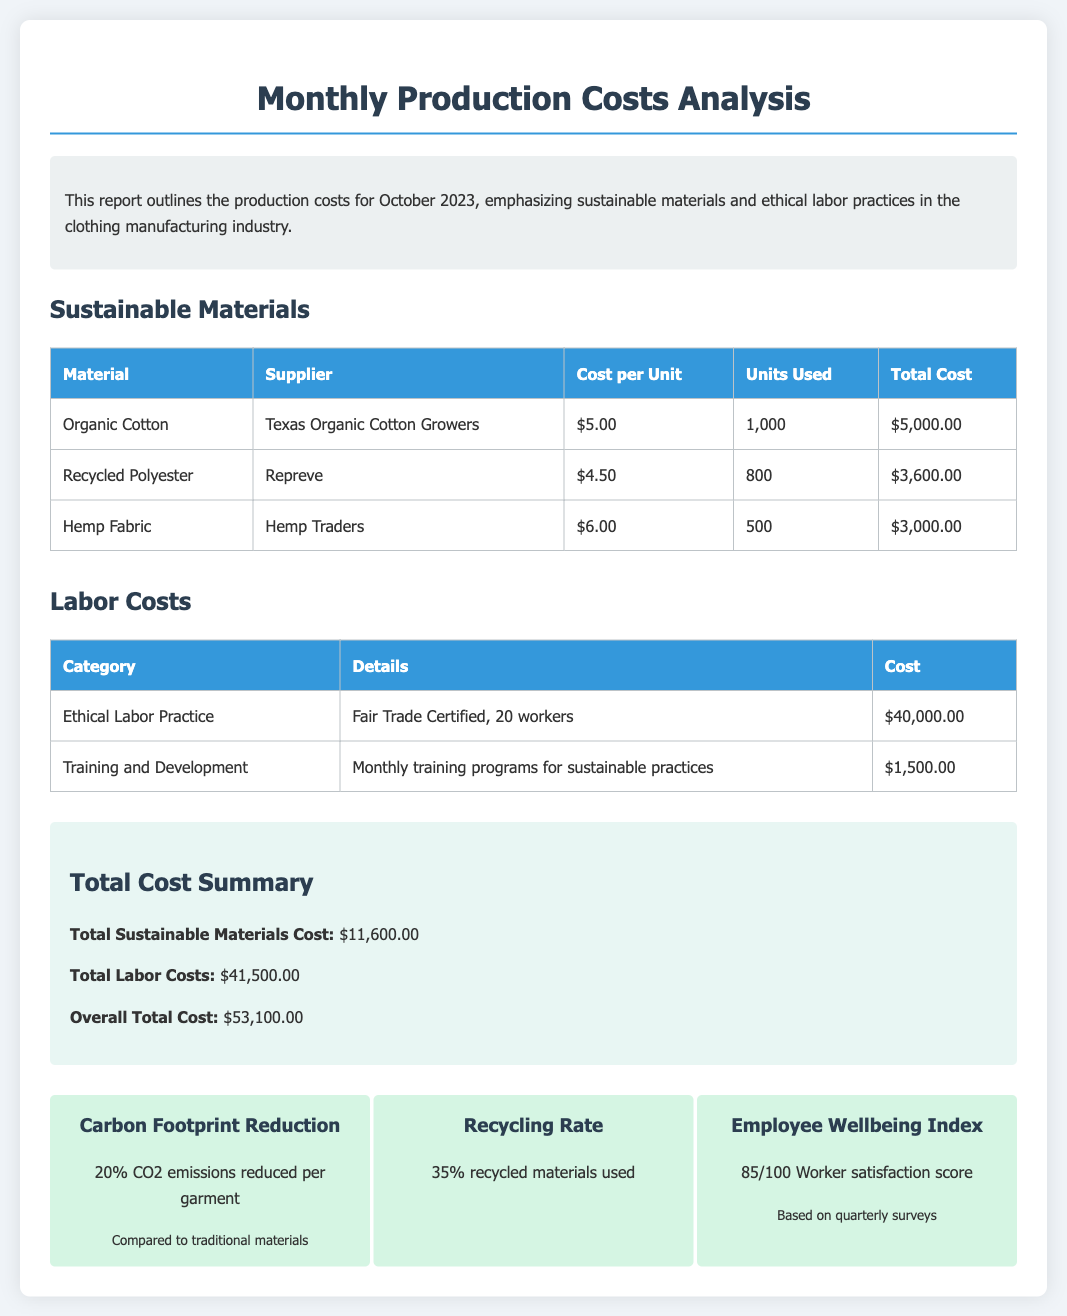What is the total cost of organic cotton? The total cost of organic cotton is listed in the sustainable materials section as $5,000.00.
Answer: $5,000.00 What percentage of the garments' CO2 emissions were reduced? The report states a 20% reduction in CO2 emissions per garment compared to traditional materials.
Answer: 20% How many units of recycled polyester were used? The document shows that 800 units of recycled polyester were used in production.
Answer: 800 What is the total labor cost? The total labor costs are summarized in the report as $41,500.00.
Answer: $41,500.00 Who is the supplier for hemp fabric? The report indicates that the hemp fabric supplier is Hemp Traders.
Answer: Hemp Traders What is the overall total cost of production for October 2023? The overall total cost is calculated and mentioned in the summary as $53,100.00.
Answer: $53,100.00 What is the score for the Employee Wellbeing Index? The Employee Wellbeing Index score is provided as 85 out of 100.
Answer: 85/100 What training expense is mentioned in the labor costs section? The expense listed is $1,500.00 for monthly training programs for sustainable practices.
Answer: $1,500.00 What percentage of recycled materials was used? The report states that 35% of recycled materials were used in production.
Answer: 35% 